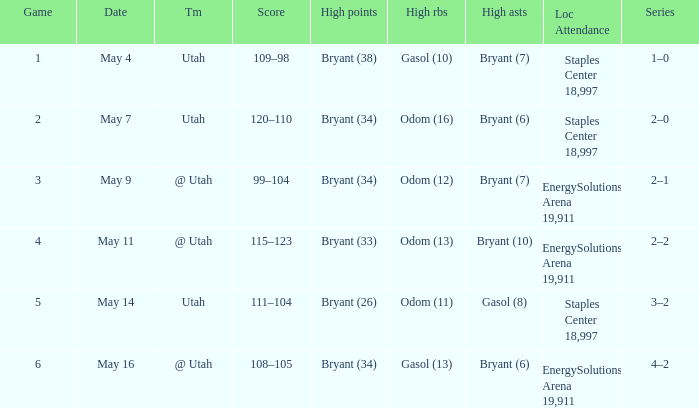What is the High rebounds with a Series with 4–2? Gasol (13). 